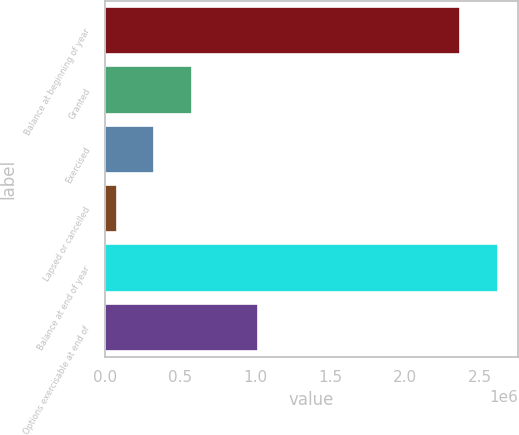Convert chart. <chart><loc_0><loc_0><loc_500><loc_500><bar_chart><fcel>Balance at beginning of year<fcel>Granted<fcel>Exercised<fcel>Lapsed or cancelled<fcel>Balance at end of year<fcel>Options exercisable at end of<nl><fcel>2.37182e+06<fcel>579344<fcel>327004<fcel>74664<fcel>2.62416e+06<fcel>1.02264e+06<nl></chart> 